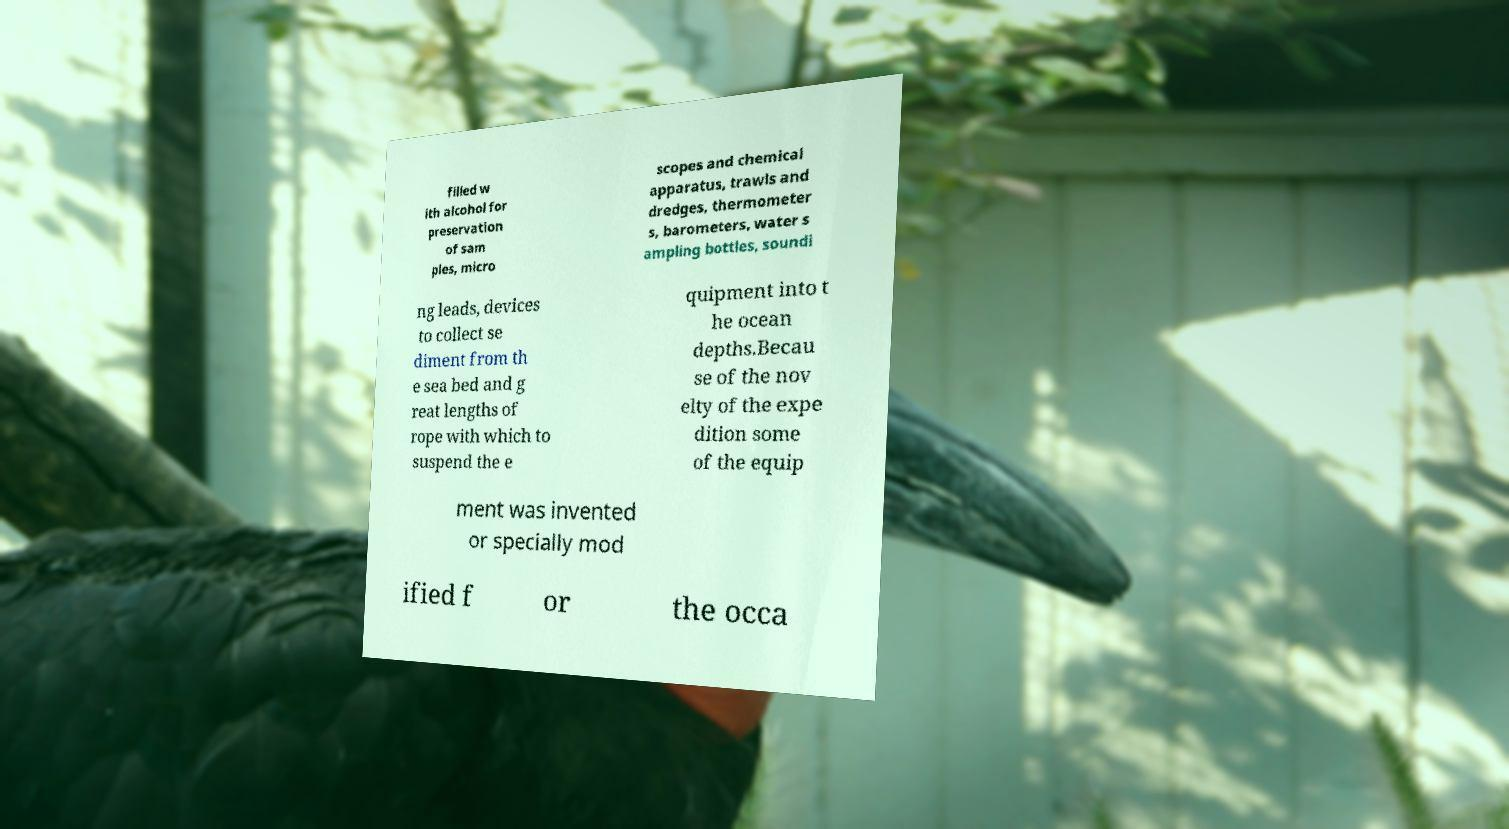Please read and relay the text visible in this image. What does it say? filled w ith alcohol for preservation of sam ples, micro scopes and chemical apparatus, trawls and dredges, thermometer s, barometers, water s ampling bottles, soundi ng leads, devices to collect se diment from th e sea bed and g reat lengths of rope with which to suspend the e quipment into t he ocean depths.Becau se of the nov elty of the expe dition some of the equip ment was invented or specially mod ified f or the occa 